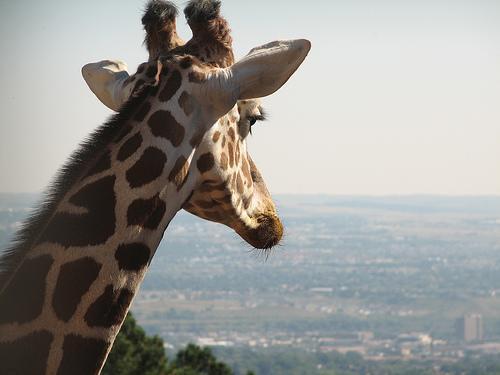How many giraffes are in the picture?
Give a very brief answer. 1. 